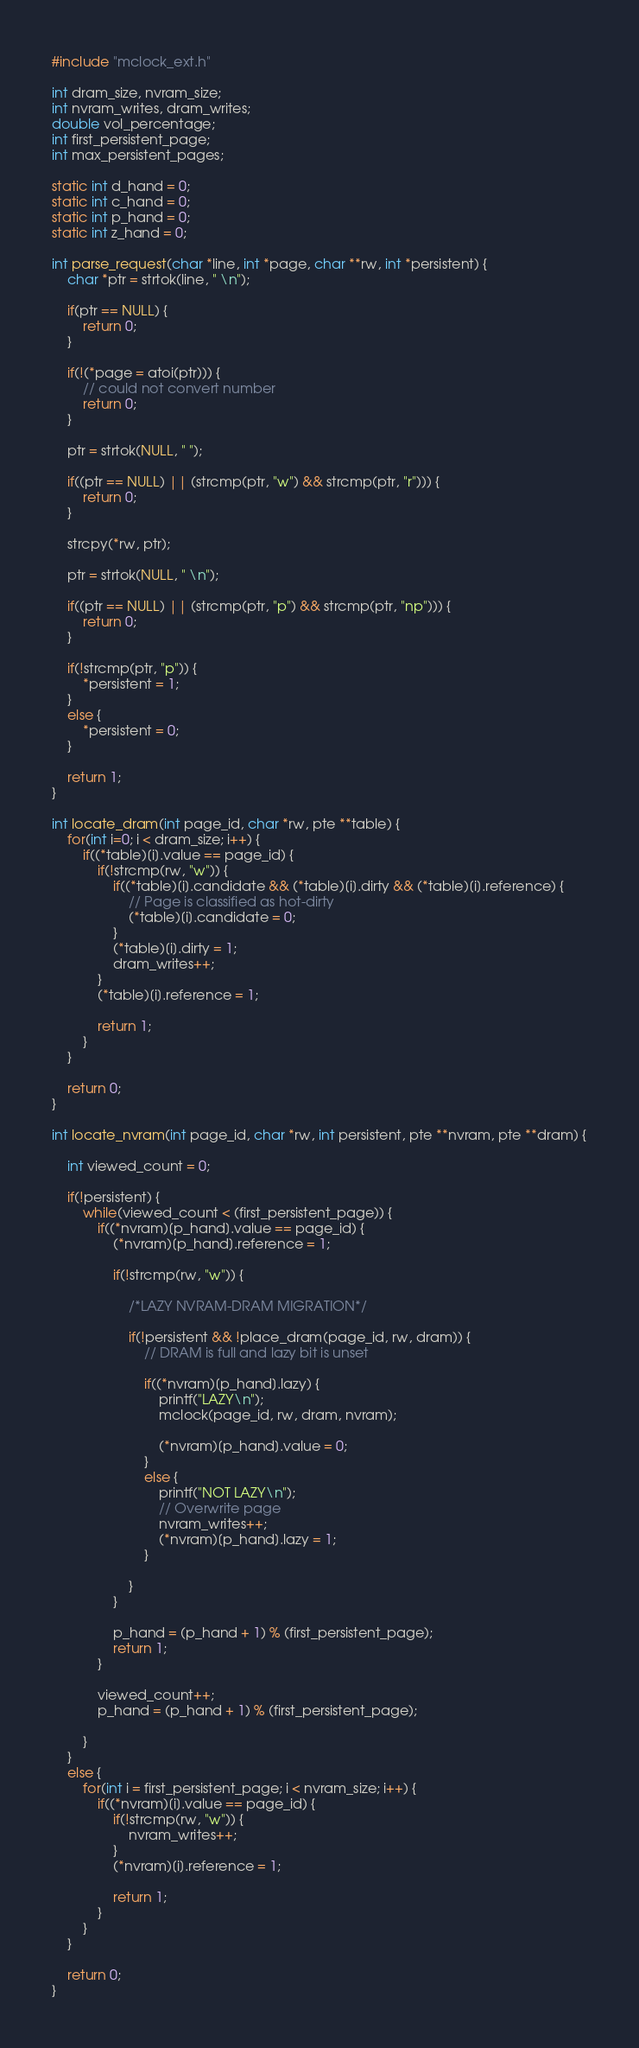<code> <loc_0><loc_0><loc_500><loc_500><_C_>#include "mclock_ext.h"

int dram_size, nvram_size;
int nvram_writes, dram_writes;
double vol_percentage;
int first_persistent_page;
int max_persistent_pages;

static int d_hand = 0;
static int c_hand = 0;
static int p_hand = 0;
static int z_hand = 0;

int parse_request(char *line, int *page, char **rw, int *persistent) {
    char *ptr = strtok(line, " \n");

    if(ptr == NULL) {
        return 0;
    }

    if(!(*page = atoi(ptr))) {
        // could not convert number
        return 0;
    }

    ptr = strtok(NULL, " ");

    if((ptr == NULL) || (strcmp(ptr, "w") && strcmp(ptr, "r"))) {
        return 0;
    }

    strcpy(*rw, ptr);

    ptr = strtok(NULL, " \n");

    if((ptr == NULL) || (strcmp(ptr, "p") && strcmp(ptr, "np"))) {
        return 0;
    }

    if(!strcmp(ptr, "p")) {
        *persistent = 1;
    }
    else {
        *persistent = 0;
    }

    return 1;
}

int locate_dram(int page_id, char *rw, pte **table) {
    for(int i=0; i < dram_size; i++) {
        if((*table)[i].value == page_id) {
            if(!strcmp(rw, "w")) {
                if((*table)[i].candidate && (*table)[i].dirty && (*table)[i].reference) {
                    // Page is classified as hot-dirty
                    (*table)[i].candidate = 0;
                }
                (*table)[i].dirty = 1;
                dram_writes++;
            }
            (*table)[i].reference = 1;

            return 1;
        }
    }

    return 0;
}

int locate_nvram(int page_id, char *rw, int persistent, pte **nvram, pte **dram) {

    int viewed_count = 0;

    if(!persistent) {
        while(viewed_count < (first_persistent_page)) {
            if((*nvram)[p_hand].value == page_id) {
                (*nvram)[p_hand].reference = 1;

                if(!strcmp(rw, "w")) {

                    /*LAZY NVRAM-DRAM MIGRATION*/

                    if(!persistent && !place_dram(page_id, rw, dram)) {
                        // DRAM is full and lazy bit is unset

                        if((*nvram)[p_hand].lazy) {
                            printf("LAZY\n");
                            mclock(page_id, rw, dram, nvram);

                            (*nvram)[p_hand].value = 0;
                        }
                        else {
                            printf("NOT LAZY\n");
                            // Overwrite page
                            nvram_writes++;
                            (*nvram)[p_hand].lazy = 1;
                        }

                    }
                }

                p_hand = (p_hand + 1) % (first_persistent_page);
                return 1;
            }

            viewed_count++;
            p_hand = (p_hand + 1) % (first_persistent_page);

        }
    }
    else {
        for(int i = first_persistent_page; i < nvram_size; i++) {
            if((*nvram)[i].value == page_id) {
                if(!strcmp(rw, "w")) {
                    nvram_writes++;
                }
                (*nvram)[i].reference = 1;

                return 1;
            }
        }
    }

    return 0;
}
</code> 